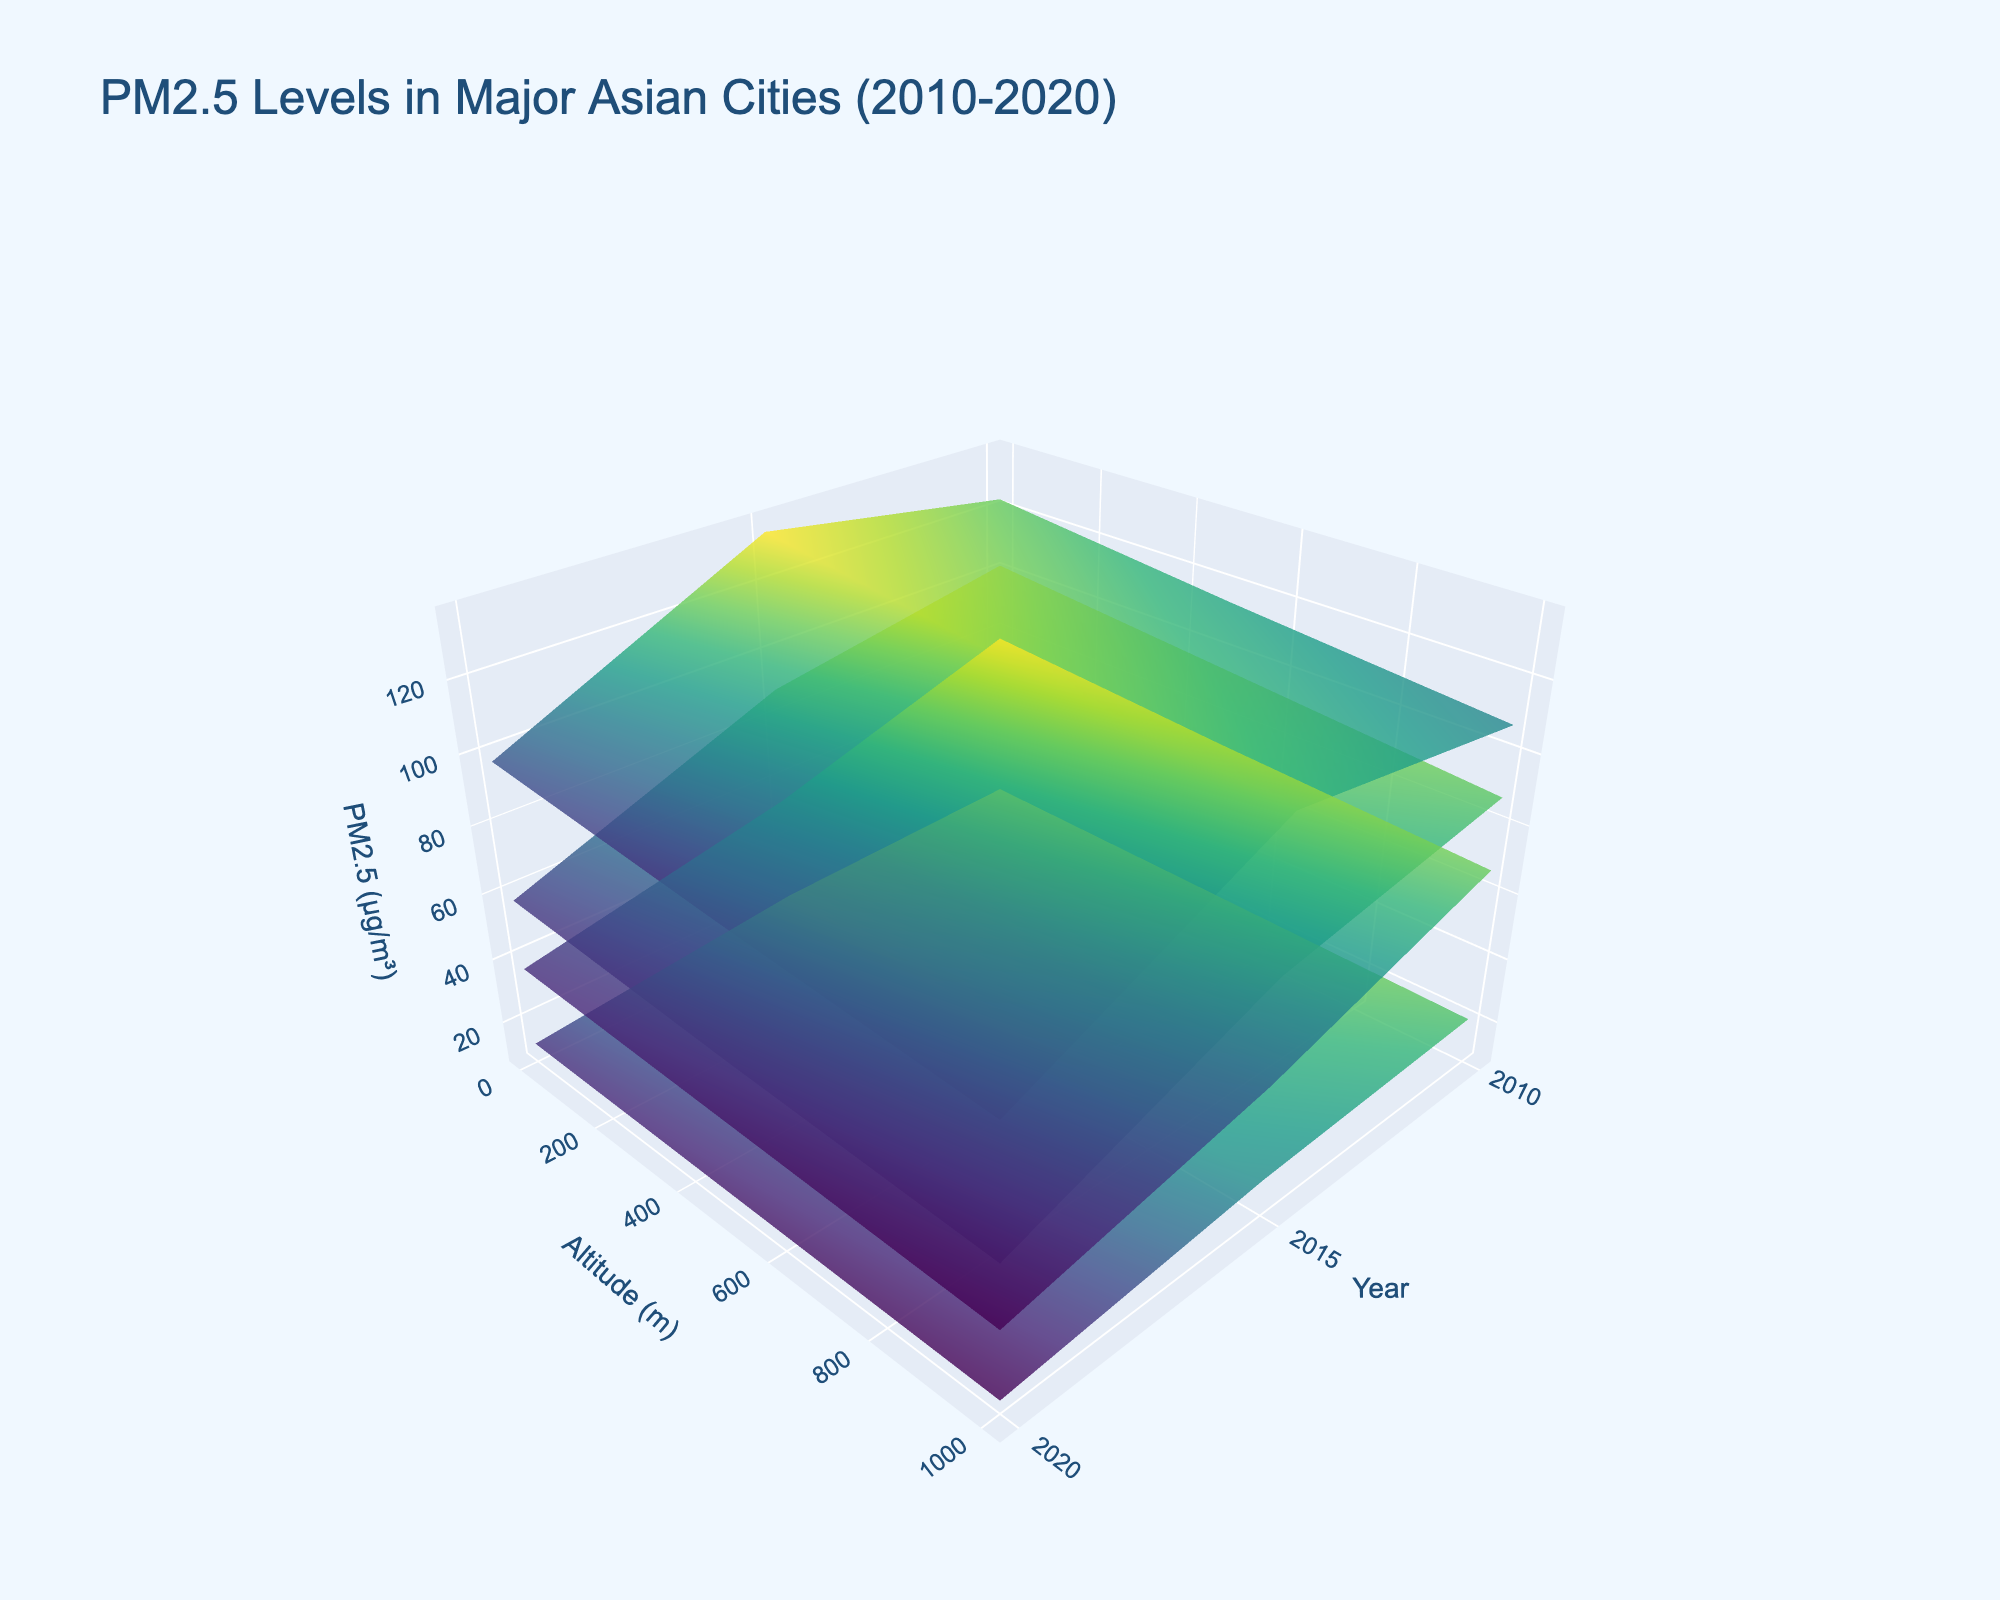What's the title of the plot? The plot's title is displayed at the top center of the figure.
Answer: PM2.5 Levels in Major Asian Cities (2010-2020) What does the Z-axis represent? The Z-axis title is provided in the plot and denotes the information shown.
Answer: PM2.5 (µg/m³) Which city had the highest PM2.5 level at ground level in 2010? Look for the data series representing the different cities and find the maximum Z value at altitude = 0 and year = 2010.
Answer: New Delhi How does PM2.5 change with altitude in Tokyo in 2020? Observe the surface plot for Tokyo at year = 2020 and note the Z values for different altitudes.
Answer: Decreases with altitude Compare the reduction in PM2.5 levels from 2010 to 2020 for Beijing at ground level and 1000 meters. Which altitude shows a greater reduction? Calculate the difference for both altitudes: at ground level (102 - 58) and at 1000 meters (88 - 49). Compare these differences.
Answer: Ground level Which city shows the smallest variation in PM2.5 levels across different altitudes in 2015? Evaluate the surface plots for each city in 2015 and identify the city with the least change in Z values across different altitudes.
Answer: Tokyo Is the trend of PM2.5 levels decreasing over the years consistent across all cities at ground level? Look at the surface plots for all cities at altitude = 0 and observe the change in Z values from 2010 to 2020.
Answer: Yes In 2015, which city had the lowest PM2.5 level at an altitude of 500 meters? Check the Z values for altitude = 500 and year = 2015 in the surface plot for each city.
Answer: Tokyo At which year did Shanghai see the largest drop in PM2.5 levels at ground level compared to the previous measurement? Compare the ground-level Z values for Shanghai between consecutive years to find the largest drop: (78 to 54), (54 to 37).
Answer: Between 2010 and 2015 Does any city have higher PM2.5 levels at 500 meters in 2015 than Tokyo's ground level in 2010? Compare Z value for each city's 2015 data at 500 meters with Tokyo’s ground level, Z value of 25 in 2010.
Answer: No 